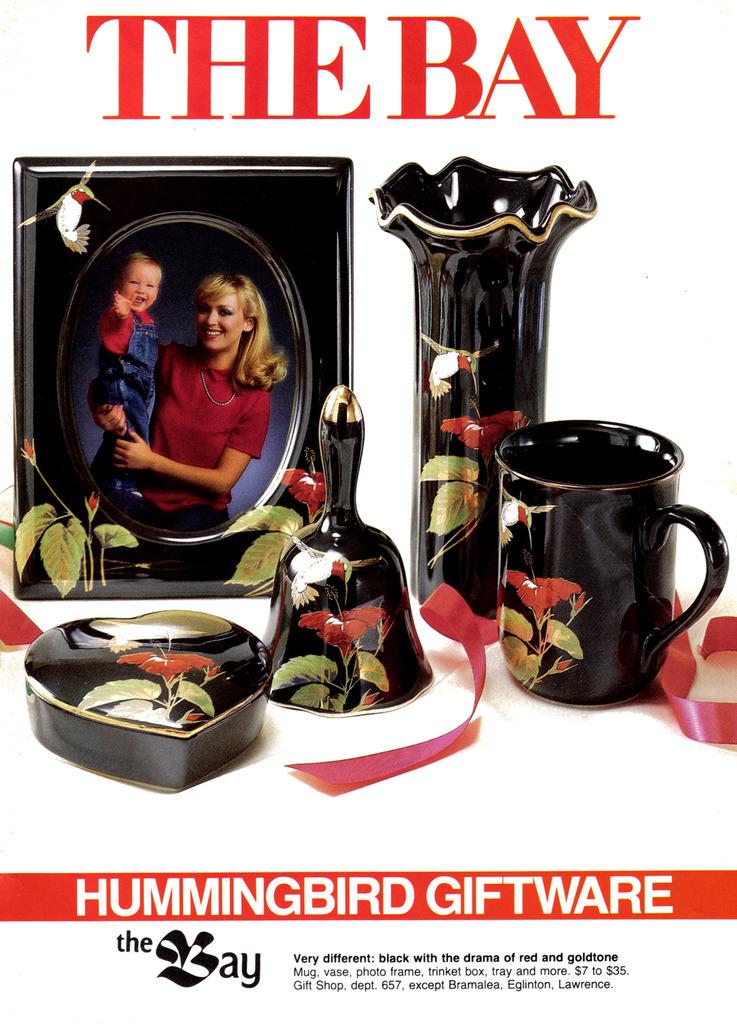What kind of giftware is this?
Offer a terse response. Hummingbird. How much does the least expensive item cost?
Your response must be concise. $7. 